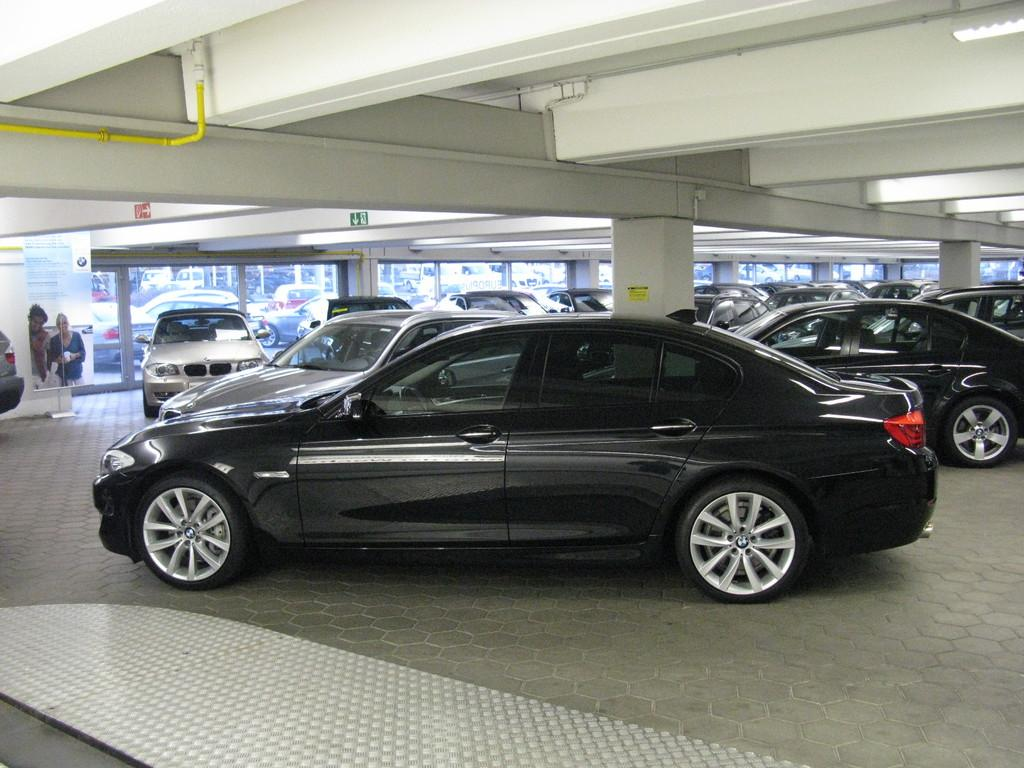What type of vehicles can be seen in the image? There are cars in the image. Can you describe any architectural features in the image? Yes, there are pillars at the ceiling in the image. Where is the frog sitting in the image? There is no frog present in the image. What type of cover is used to protect the cars from fire in the image? There is no mention of a cover or fire in the image; it only features cars and pillars at the ceiling. 